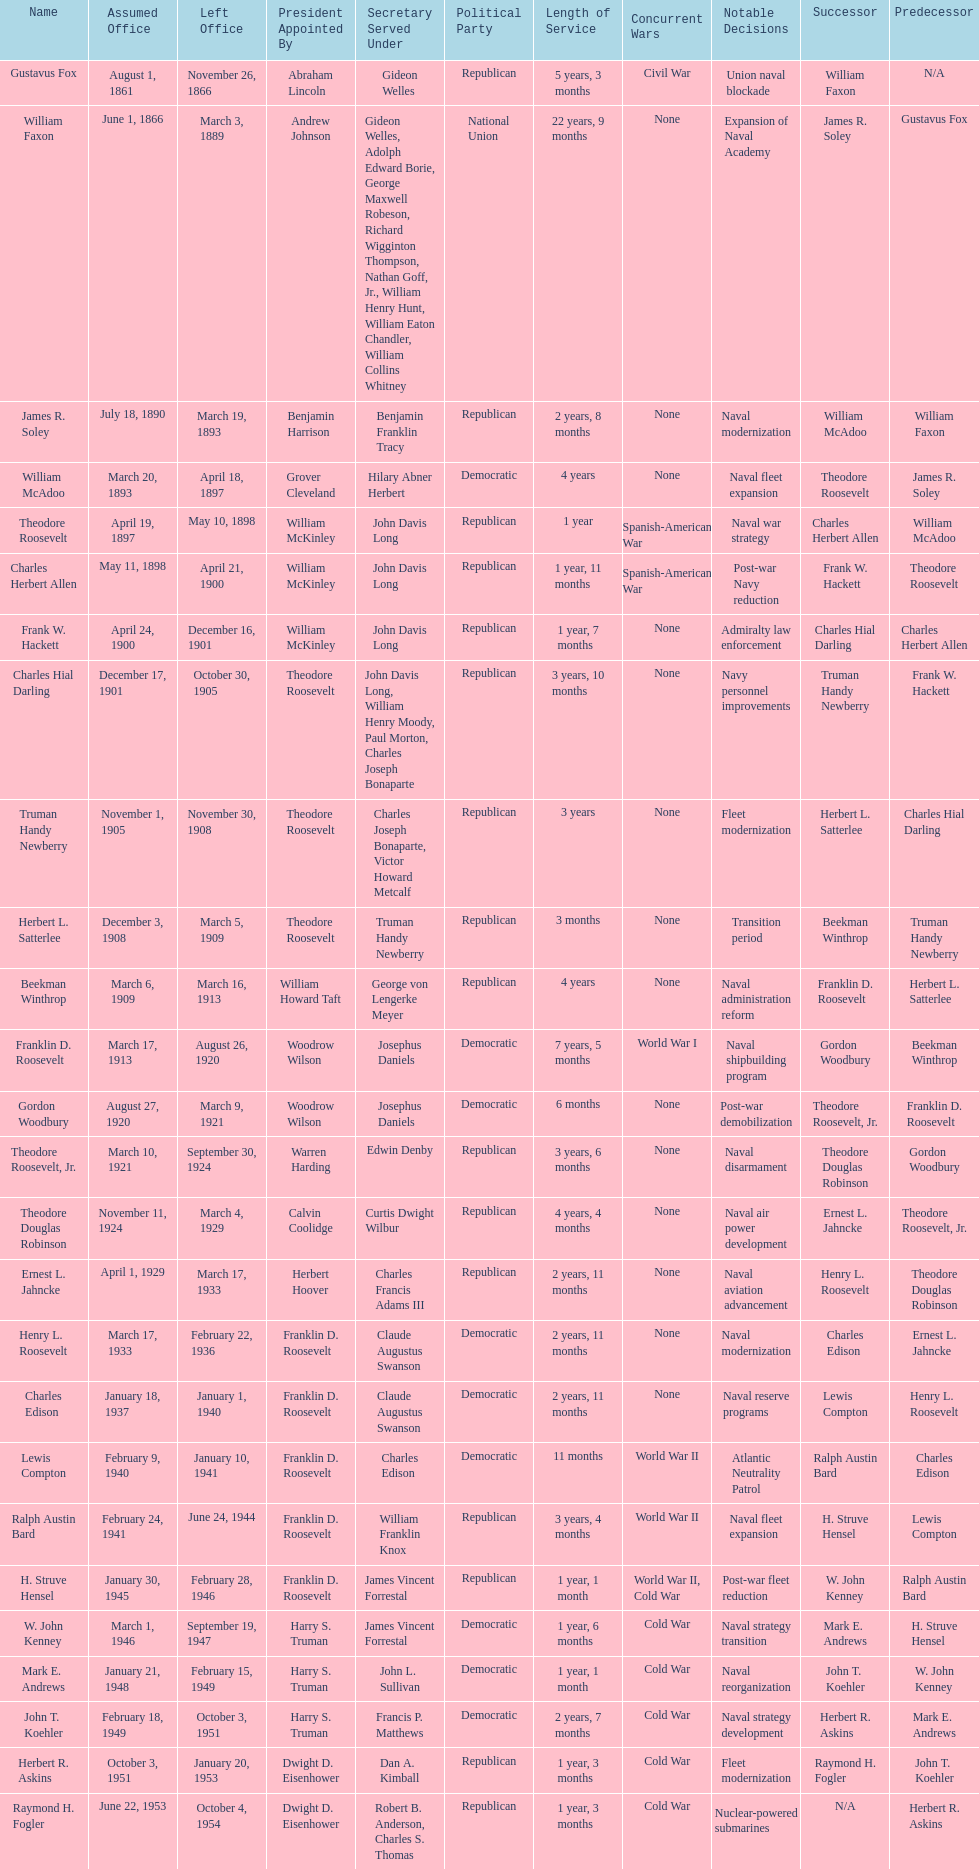When did raymond h. fogler leave the office of assistant secretary of the navy? October 4, 1954. 